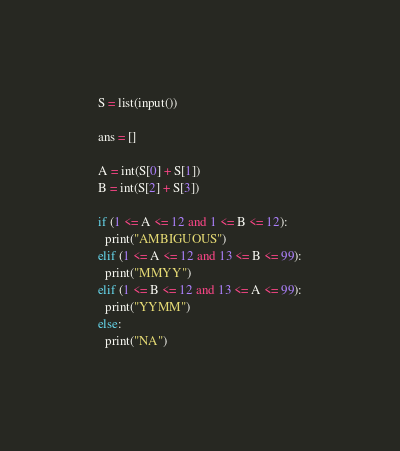<code> <loc_0><loc_0><loc_500><loc_500><_Python_>S = list(input())

ans = []

A = int(S[0] + S[1])
B = int(S[2] + S[3])

if (1 <= A <= 12 and 1 <= B <= 12):
  print("AMBIGUOUS")
elif (1 <= A <= 12 and 13 <= B <= 99):
  print("MMYY")
elif (1 <= B <= 12 and 13 <= A <= 99):
  print("YYMM")
else:
  print("NA")
</code> 